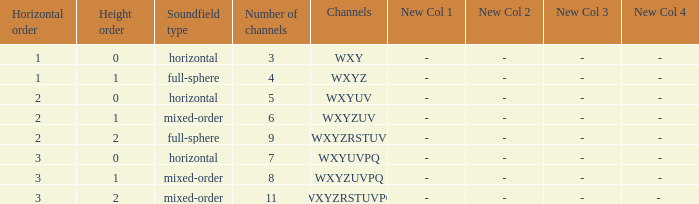If the height order is 1 and the soundfield type is mixed-order, what are all the channels? WXYZUV, WXYZUVPQ. 